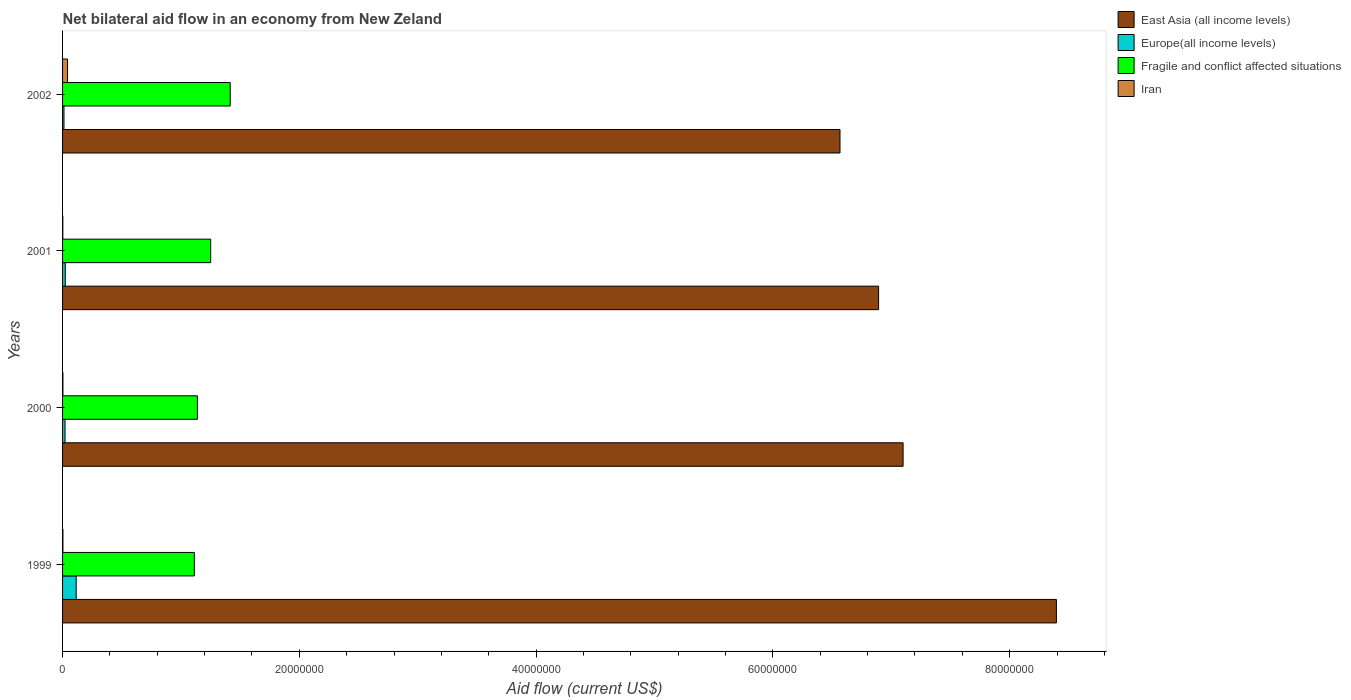Are the number of bars on each tick of the Y-axis equal?
Ensure brevity in your answer.  Yes. In how many cases, is the number of bars for a given year not equal to the number of legend labels?
Give a very brief answer. 0. What is the net bilateral aid flow in East Asia (all income levels) in 2000?
Your answer should be very brief. 7.10e+07. Across all years, what is the maximum net bilateral aid flow in Fragile and conflict affected situations?
Offer a terse response. 1.42e+07. Across all years, what is the minimum net bilateral aid flow in Fragile and conflict affected situations?
Your answer should be compact. 1.11e+07. In which year was the net bilateral aid flow in Iran minimum?
Your response must be concise. 2001. What is the total net bilateral aid flow in East Asia (all income levels) in the graph?
Make the answer very short. 2.90e+08. What is the difference between the net bilateral aid flow in East Asia (all income levels) in 2000 and that in 2002?
Provide a short and direct response. 5.33e+06. What is the difference between the net bilateral aid flow in East Asia (all income levels) in 2000 and the net bilateral aid flow in Iran in 2001?
Provide a succinct answer. 7.10e+07. What is the average net bilateral aid flow in Europe(all income levels) per year?
Offer a very short reply. 4.28e+05. In the year 2000, what is the difference between the net bilateral aid flow in Fragile and conflict affected situations and net bilateral aid flow in Iran?
Your answer should be compact. 1.14e+07. What is the ratio of the net bilateral aid flow in East Asia (all income levels) in 1999 to that in 2001?
Your answer should be very brief. 1.22. Is the difference between the net bilateral aid flow in Fragile and conflict affected situations in 1999 and 2001 greater than the difference between the net bilateral aid flow in Iran in 1999 and 2001?
Make the answer very short. No. What is the difference between the highest and the lowest net bilateral aid flow in Europe(all income levels)?
Offer a terse response. 1.03e+06. Is the sum of the net bilateral aid flow in East Asia (all income levels) in 2001 and 2002 greater than the maximum net bilateral aid flow in Fragile and conflict affected situations across all years?
Offer a very short reply. Yes. Is it the case that in every year, the sum of the net bilateral aid flow in Iran and net bilateral aid flow in East Asia (all income levels) is greater than the sum of net bilateral aid flow in Europe(all income levels) and net bilateral aid flow in Fragile and conflict affected situations?
Ensure brevity in your answer.  Yes. What does the 3rd bar from the top in 2002 represents?
Give a very brief answer. Europe(all income levels). What does the 1st bar from the bottom in 2002 represents?
Ensure brevity in your answer.  East Asia (all income levels). Is it the case that in every year, the sum of the net bilateral aid flow in Iran and net bilateral aid flow in Europe(all income levels) is greater than the net bilateral aid flow in East Asia (all income levels)?
Your answer should be compact. No. How many years are there in the graph?
Your answer should be very brief. 4. Does the graph contain grids?
Your answer should be very brief. No. Where does the legend appear in the graph?
Provide a succinct answer. Top right. How many legend labels are there?
Provide a succinct answer. 4. What is the title of the graph?
Give a very brief answer. Net bilateral aid flow in an economy from New Zeland. Does "World" appear as one of the legend labels in the graph?
Your response must be concise. No. What is the label or title of the X-axis?
Provide a short and direct response. Aid flow (current US$). What is the Aid flow (current US$) of East Asia (all income levels) in 1999?
Keep it short and to the point. 8.40e+07. What is the Aid flow (current US$) of Europe(all income levels) in 1999?
Keep it short and to the point. 1.15e+06. What is the Aid flow (current US$) of Fragile and conflict affected situations in 1999?
Provide a short and direct response. 1.11e+07. What is the Aid flow (current US$) in Iran in 1999?
Make the answer very short. 3.00e+04. What is the Aid flow (current US$) in East Asia (all income levels) in 2000?
Your answer should be very brief. 7.10e+07. What is the Aid flow (current US$) of Europe(all income levels) in 2000?
Make the answer very short. 2.10e+05. What is the Aid flow (current US$) of Fragile and conflict affected situations in 2000?
Ensure brevity in your answer.  1.14e+07. What is the Aid flow (current US$) in East Asia (all income levels) in 2001?
Offer a terse response. 6.89e+07. What is the Aid flow (current US$) of Fragile and conflict affected situations in 2001?
Offer a very short reply. 1.25e+07. What is the Aid flow (current US$) in East Asia (all income levels) in 2002?
Give a very brief answer. 6.57e+07. What is the Aid flow (current US$) in Fragile and conflict affected situations in 2002?
Your answer should be compact. 1.42e+07. Across all years, what is the maximum Aid flow (current US$) in East Asia (all income levels)?
Ensure brevity in your answer.  8.40e+07. Across all years, what is the maximum Aid flow (current US$) in Europe(all income levels)?
Your answer should be compact. 1.15e+06. Across all years, what is the maximum Aid flow (current US$) of Fragile and conflict affected situations?
Make the answer very short. 1.42e+07. Across all years, what is the maximum Aid flow (current US$) of Iran?
Keep it short and to the point. 4.20e+05. Across all years, what is the minimum Aid flow (current US$) of East Asia (all income levels)?
Your response must be concise. 6.57e+07. Across all years, what is the minimum Aid flow (current US$) in Europe(all income levels)?
Give a very brief answer. 1.20e+05. Across all years, what is the minimum Aid flow (current US$) in Fragile and conflict affected situations?
Offer a terse response. 1.11e+07. What is the total Aid flow (current US$) of East Asia (all income levels) in the graph?
Provide a short and direct response. 2.90e+08. What is the total Aid flow (current US$) of Europe(all income levels) in the graph?
Your answer should be compact. 1.71e+06. What is the total Aid flow (current US$) of Fragile and conflict affected situations in the graph?
Your response must be concise. 4.92e+07. What is the difference between the Aid flow (current US$) in East Asia (all income levels) in 1999 and that in 2000?
Offer a terse response. 1.30e+07. What is the difference between the Aid flow (current US$) of Europe(all income levels) in 1999 and that in 2000?
Ensure brevity in your answer.  9.40e+05. What is the difference between the Aid flow (current US$) in Fragile and conflict affected situations in 1999 and that in 2000?
Give a very brief answer. -2.60e+05. What is the difference between the Aid flow (current US$) of Iran in 1999 and that in 2000?
Give a very brief answer. 0. What is the difference between the Aid flow (current US$) in East Asia (all income levels) in 1999 and that in 2001?
Provide a short and direct response. 1.50e+07. What is the difference between the Aid flow (current US$) of Europe(all income levels) in 1999 and that in 2001?
Your answer should be compact. 9.20e+05. What is the difference between the Aid flow (current US$) in Fragile and conflict affected situations in 1999 and that in 2001?
Keep it short and to the point. -1.38e+06. What is the difference between the Aid flow (current US$) in Iran in 1999 and that in 2001?
Your response must be concise. 10000. What is the difference between the Aid flow (current US$) of East Asia (all income levels) in 1999 and that in 2002?
Your answer should be compact. 1.83e+07. What is the difference between the Aid flow (current US$) of Europe(all income levels) in 1999 and that in 2002?
Your answer should be compact. 1.03e+06. What is the difference between the Aid flow (current US$) of Fragile and conflict affected situations in 1999 and that in 2002?
Keep it short and to the point. -3.03e+06. What is the difference between the Aid flow (current US$) in Iran in 1999 and that in 2002?
Ensure brevity in your answer.  -3.90e+05. What is the difference between the Aid flow (current US$) of East Asia (all income levels) in 2000 and that in 2001?
Make the answer very short. 2.07e+06. What is the difference between the Aid flow (current US$) of Europe(all income levels) in 2000 and that in 2001?
Provide a short and direct response. -2.00e+04. What is the difference between the Aid flow (current US$) in Fragile and conflict affected situations in 2000 and that in 2001?
Offer a terse response. -1.12e+06. What is the difference between the Aid flow (current US$) of East Asia (all income levels) in 2000 and that in 2002?
Provide a short and direct response. 5.33e+06. What is the difference between the Aid flow (current US$) in Fragile and conflict affected situations in 2000 and that in 2002?
Offer a very short reply. -2.77e+06. What is the difference between the Aid flow (current US$) in Iran in 2000 and that in 2002?
Keep it short and to the point. -3.90e+05. What is the difference between the Aid flow (current US$) of East Asia (all income levels) in 2001 and that in 2002?
Ensure brevity in your answer.  3.26e+06. What is the difference between the Aid flow (current US$) in Fragile and conflict affected situations in 2001 and that in 2002?
Make the answer very short. -1.65e+06. What is the difference between the Aid flow (current US$) in Iran in 2001 and that in 2002?
Give a very brief answer. -4.00e+05. What is the difference between the Aid flow (current US$) of East Asia (all income levels) in 1999 and the Aid flow (current US$) of Europe(all income levels) in 2000?
Provide a short and direct response. 8.37e+07. What is the difference between the Aid flow (current US$) of East Asia (all income levels) in 1999 and the Aid flow (current US$) of Fragile and conflict affected situations in 2000?
Offer a terse response. 7.26e+07. What is the difference between the Aid flow (current US$) in East Asia (all income levels) in 1999 and the Aid flow (current US$) in Iran in 2000?
Provide a succinct answer. 8.39e+07. What is the difference between the Aid flow (current US$) of Europe(all income levels) in 1999 and the Aid flow (current US$) of Fragile and conflict affected situations in 2000?
Provide a succinct answer. -1.02e+07. What is the difference between the Aid flow (current US$) of Europe(all income levels) in 1999 and the Aid flow (current US$) of Iran in 2000?
Offer a very short reply. 1.12e+06. What is the difference between the Aid flow (current US$) in Fragile and conflict affected situations in 1999 and the Aid flow (current US$) in Iran in 2000?
Offer a very short reply. 1.11e+07. What is the difference between the Aid flow (current US$) of East Asia (all income levels) in 1999 and the Aid flow (current US$) of Europe(all income levels) in 2001?
Offer a terse response. 8.37e+07. What is the difference between the Aid flow (current US$) in East Asia (all income levels) in 1999 and the Aid flow (current US$) in Fragile and conflict affected situations in 2001?
Ensure brevity in your answer.  7.14e+07. What is the difference between the Aid flow (current US$) of East Asia (all income levels) in 1999 and the Aid flow (current US$) of Iran in 2001?
Your answer should be very brief. 8.39e+07. What is the difference between the Aid flow (current US$) in Europe(all income levels) in 1999 and the Aid flow (current US$) in Fragile and conflict affected situations in 2001?
Provide a short and direct response. -1.14e+07. What is the difference between the Aid flow (current US$) in Europe(all income levels) in 1999 and the Aid flow (current US$) in Iran in 2001?
Ensure brevity in your answer.  1.13e+06. What is the difference between the Aid flow (current US$) in Fragile and conflict affected situations in 1999 and the Aid flow (current US$) in Iran in 2001?
Offer a terse response. 1.11e+07. What is the difference between the Aid flow (current US$) of East Asia (all income levels) in 1999 and the Aid flow (current US$) of Europe(all income levels) in 2002?
Your answer should be very brief. 8.38e+07. What is the difference between the Aid flow (current US$) in East Asia (all income levels) in 1999 and the Aid flow (current US$) in Fragile and conflict affected situations in 2002?
Ensure brevity in your answer.  6.98e+07. What is the difference between the Aid flow (current US$) in East Asia (all income levels) in 1999 and the Aid flow (current US$) in Iran in 2002?
Make the answer very short. 8.35e+07. What is the difference between the Aid flow (current US$) of Europe(all income levels) in 1999 and the Aid flow (current US$) of Fragile and conflict affected situations in 2002?
Your response must be concise. -1.30e+07. What is the difference between the Aid flow (current US$) in Europe(all income levels) in 1999 and the Aid flow (current US$) in Iran in 2002?
Offer a very short reply. 7.30e+05. What is the difference between the Aid flow (current US$) in Fragile and conflict affected situations in 1999 and the Aid flow (current US$) in Iran in 2002?
Offer a terse response. 1.07e+07. What is the difference between the Aid flow (current US$) in East Asia (all income levels) in 2000 and the Aid flow (current US$) in Europe(all income levels) in 2001?
Offer a very short reply. 7.08e+07. What is the difference between the Aid flow (current US$) in East Asia (all income levels) in 2000 and the Aid flow (current US$) in Fragile and conflict affected situations in 2001?
Give a very brief answer. 5.85e+07. What is the difference between the Aid flow (current US$) of East Asia (all income levels) in 2000 and the Aid flow (current US$) of Iran in 2001?
Your response must be concise. 7.10e+07. What is the difference between the Aid flow (current US$) in Europe(all income levels) in 2000 and the Aid flow (current US$) in Fragile and conflict affected situations in 2001?
Give a very brief answer. -1.23e+07. What is the difference between the Aid flow (current US$) in Fragile and conflict affected situations in 2000 and the Aid flow (current US$) in Iran in 2001?
Your response must be concise. 1.14e+07. What is the difference between the Aid flow (current US$) in East Asia (all income levels) in 2000 and the Aid flow (current US$) in Europe(all income levels) in 2002?
Provide a succinct answer. 7.09e+07. What is the difference between the Aid flow (current US$) of East Asia (all income levels) in 2000 and the Aid flow (current US$) of Fragile and conflict affected situations in 2002?
Offer a very short reply. 5.68e+07. What is the difference between the Aid flow (current US$) of East Asia (all income levels) in 2000 and the Aid flow (current US$) of Iran in 2002?
Offer a very short reply. 7.06e+07. What is the difference between the Aid flow (current US$) in Europe(all income levels) in 2000 and the Aid flow (current US$) in Fragile and conflict affected situations in 2002?
Provide a succinct answer. -1.40e+07. What is the difference between the Aid flow (current US$) of Europe(all income levels) in 2000 and the Aid flow (current US$) of Iran in 2002?
Your answer should be very brief. -2.10e+05. What is the difference between the Aid flow (current US$) in Fragile and conflict affected situations in 2000 and the Aid flow (current US$) in Iran in 2002?
Ensure brevity in your answer.  1.10e+07. What is the difference between the Aid flow (current US$) of East Asia (all income levels) in 2001 and the Aid flow (current US$) of Europe(all income levels) in 2002?
Your answer should be very brief. 6.88e+07. What is the difference between the Aid flow (current US$) of East Asia (all income levels) in 2001 and the Aid flow (current US$) of Fragile and conflict affected situations in 2002?
Make the answer very short. 5.48e+07. What is the difference between the Aid flow (current US$) in East Asia (all income levels) in 2001 and the Aid flow (current US$) in Iran in 2002?
Offer a very short reply. 6.85e+07. What is the difference between the Aid flow (current US$) in Europe(all income levels) in 2001 and the Aid flow (current US$) in Fragile and conflict affected situations in 2002?
Your answer should be compact. -1.39e+07. What is the difference between the Aid flow (current US$) in Fragile and conflict affected situations in 2001 and the Aid flow (current US$) in Iran in 2002?
Provide a short and direct response. 1.21e+07. What is the average Aid flow (current US$) in East Asia (all income levels) per year?
Ensure brevity in your answer.  7.24e+07. What is the average Aid flow (current US$) in Europe(all income levels) per year?
Provide a short and direct response. 4.28e+05. What is the average Aid flow (current US$) of Fragile and conflict affected situations per year?
Offer a terse response. 1.23e+07. What is the average Aid flow (current US$) of Iran per year?
Your answer should be compact. 1.25e+05. In the year 1999, what is the difference between the Aid flow (current US$) of East Asia (all income levels) and Aid flow (current US$) of Europe(all income levels)?
Ensure brevity in your answer.  8.28e+07. In the year 1999, what is the difference between the Aid flow (current US$) in East Asia (all income levels) and Aid flow (current US$) in Fragile and conflict affected situations?
Your answer should be compact. 7.28e+07. In the year 1999, what is the difference between the Aid flow (current US$) in East Asia (all income levels) and Aid flow (current US$) in Iran?
Provide a succinct answer. 8.39e+07. In the year 1999, what is the difference between the Aid flow (current US$) of Europe(all income levels) and Aid flow (current US$) of Fragile and conflict affected situations?
Give a very brief answer. -9.98e+06. In the year 1999, what is the difference between the Aid flow (current US$) in Europe(all income levels) and Aid flow (current US$) in Iran?
Keep it short and to the point. 1.12e+06. In the year 1999, what is the difference between the Aid flow (current US$) in Fragile and conflict affected situations and Aid flow (current US$) in Iran?
Provide a succinct answer. 1.11e+07. In the year 2000, what is the difference between the Aid flow (current US$) in East Asia (all income levels) and Aid flow (current US$) in Europe(all income levels)?
Offer a very short reply. 7.08e+07. In the year 2000, what is the difference between the Aid flow (current US$) of East Asia (all income levels) and Aid flow (current US$) of Fragile and conflict affected situations?
Make the answer very short. 5.96e+07. In the year 2000, what is the difference between the Aid flow (current US$) in East Asia (all income levels) and Aid flow (current US$) in Iran?
Provide a succinct answer. 7.10e+07. In the year 2000, what is the difference between the Aid flow (current US$) of Europe(all income levels) and Aid flow (current US$) of Fragile and conflict affected situations?
Offer a very short reply. -1.12e+07. In the year 2000, what is the difference between the Aid flow (current US$) of Europe(all income levels) and Aid flow (current US$) of Iran?
Make the answer very short. 1.80e+05. In the year 2000, what is the difference between the Aid flow (current US$) of Fragile and conflict affected situations and Aid flow (current US$) of Iran?
Make the answer very short. 1.14e+07. In the year 2001, what is the difference between the Aid flow (current US$) in East Asia (all income levels) and Aid flow (current US$) in Europe(all income levels)?
Make the answer very short. 6.87e+07. In the year 2001, what is the difference between the Aid flow (current US$) of East Asia (all income levels) and Aid flow (current US$) of Fragile and conflict affected situations?
Provide a short and direct response. 5.64e+07. In the year 2001, what is the difference between the Aid flow (current US$) of East Asia (all income levels) and Aid flow (current US$) of Iran?
Offer a very short reply. 6.89e+07. In the year 2001, what is the difference between the Aid flow (current US$) in Europe(all income levels) and Aid flow (current US$) in Fragile and conflict affected situations?
Your answer should be very brief. -1.23e+07. In the year 2001, what is the difference between the Aid flow (current US$) in Fragile and conflict affected situations and Aid flow (current US$) in Iran?
Make the answer very short. 1.25e+07. In the year 2002, what is the difference between the Aid flow (current US$) in East Asia (all income levels) and Aid flow (current US$) in Europe(all income levels)?
Make the answer very short. 6.56e+07. In the year 2002, what is the difference between the Aid flow (current US$) of East Asia (all income levels) and Aid flow (current US$) of Fragile and conflict affected situations?
Provide a succinct answer. 5.15e+07. In the year 2002, what is the difference between the Aid flow (current US$) in East Asia (all income levels) and Aid flow (current US$) in Iran?
Offer a very short reply. 6.52e+07. In the year 2002, what is the difference between the Aid flow (current US$) in Europe(all income levels) and Aid flow (current US$) in Fragile and conflict affected situations?
Keep it short and to the point. -1.40e+07. In the year 2002, what is the difference between the Aid flow (current US$) of Europe(all income levels) and Aid flow (current US$) of Iran?
Your answer should be compact. -3.00e+05. In the year 2002, what is the difference between the Aid flow (current US$) of Fragile and conflict affected situations and Aid flow (current US$) of Iran?
Your answer should be very brief. 1.37e+07. What is the ratio of the Aid flow (current US$) in East Asia (all income levels) in 1999 to that in 2000?
Your answer should be very brief. 1.18. What is the ratio of the Aid flow (current US$) in Europe(all income levels) in 1999 to that in 2000?
Provide a short and direct response. 5.48. What is the ratio of the Aid flow (current US$) in Fragile and conflict affected situations in 1999 to that in 2000?
Keep it short and to the point. 0.98. What is the ratio of the Aid flow (current US$) in East Asia (all income levels) in 1999 to that in 2001?
Provide a succinct answer. 1.22. What is the ratio of the Aid flow (current US$) in Europe(all income levels) in 1999 to that in 2001?
Provide a succinct answer. 5. What is the ratio of the Aid flow (current US$) of Fragile and conflict affected situations in 1999 to that in 2001?
Keep it short and to the point. 0.89. What is the ratio of the Aid flow (current US$) of Iran in 1999 to that in 2001?
Your response must be concise. 1.5. What is the ratio of the Aid flow (current US$) of East Asia (all income levels) in 1999 to that in 2002?
Provide a short and direct response. 1.28. What is the ratio of the Aid flow (current US$) in Europe(all income levels) in 1999 to that in 2002?
Your answer should be compact. 9.58. What is the ratio of the Aid flow (current US$) of Fragile and conflict affected situations in 1999 to that in 2002?
Make the answer very short. 0.79. What is the ratio of the Aid flow (current US$) in Iran in 1999 to that in 2002?
Make the answer very short. 0.07. What is the ratio of the Aid flow (current US$) in Europe(all income levels) in 2000 to that in 2001?
Make the answer very short. 0.91. What is the ratio of the Aid flow (current US$) of Fragile and conflict affected situations in 2000 to that in 2001?
Make the answer very short. 0.91. What is the ratio of the Aid flow (current US$) of Iran in 2000 to that in 2001?
Offer a very short reply. 1.5. What is the ratio of the Aid flow (current US$) in East Asia (all income levels) in 2000 to that in 2002?
Give a very brief answer. 1.08. What is the ratio of the Aid flow (current US$) of Europe(all income levels) in 2000 to that in 2002?
Your response must be concise. 1.75. What is the ratio of the Aid flow (current US$) in Fragile and conflict affected situations in 2000 to that in 2002?
Provide a succinct answer. 0.8. What is the ratio of the Aid flow (current US$) in Iran in 2000 to that in 2002?
Make the answer very short. 0.07. What is the ratio of the Aid flow (current US$) in East Asia (all income levels) in 2001 to that in 2002?
Your answer should be compact. 1.05. What is the ratio of the Aid flow (current US$) in Europe(all income levels) in 2001 to that in 2002?
Ensure brevity in your answer.  1.92. What is the ratio of the Aid flow (current US$) in Fragile and conflict affected situations in 2001 to that in 2002?
Your answer should be very brief. 0.88. What is the ratio of the Aid flow (current US$) of Iran in 2001 to that in 2002?
Ensure brevity in your answer.  0.05. What is the difference between the highest and the second highest Aid flow (current US$) of East Asia (all income levels)?
Make the answer very short. 1.30e+07. What is the difference between the highest and the second highest Aid flow (current US$) in Europe(all income levels)?
Your response must be concise. 9.20e+05. What is the difference between the highest and the second highest Aid flow (current US$) of Fragile and conflict affected situations?
Give a very brief answer. 1.65e+06. What is the difference between the highest and the lowest Aid flow (current US$) of East Asia (all income levels)?
Offer a very short reply. 1.83e+07. What is the difference between the highest and the lowest Aid flow (current US$) of Europe(all income levels)?
Make the answer very short. 1.03e+06. What is the difference between the highest and the lowest Aid flow (current US$) in Fragile and conflict affected situations?
Offer a very short reply. 3.03e+06. What is the difference between the highest and the lowest Aid flow (current US$) of Iran?
Offer a terse response. 4.00e+05. 